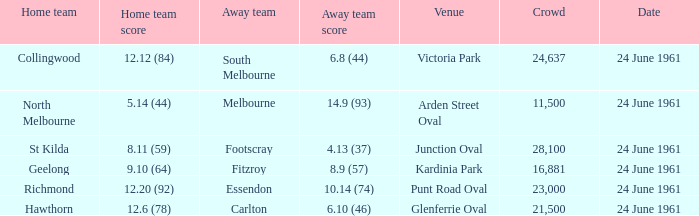What is the date of the match where the home team scored 24 June 1961. I'm looking to parse the entire table for insights. Could you assist me with that? {'header': ['Home team', 'Home team score', 'Away team', 'Away team score', 'Venue', 'Crowd', 'Date'], 'rows': [['Collingwood', '12.12 (84)', 'South Melbourne', '6.8 (44)', 'Victoria Park', '24,637', '24 June 1961'], ['North Melbourne', '5.14 (44)', 'Melbourne', '14.9 (93)', 'Arden Street Oval', '11,500', '24 June 1961'], ['St Kilda', '8.11 (59)', 'Footscray', '4.13 (37)', 'Junction Oval', '28,100', '24 June 1961'], ['Geelong', '9.10 (64)', 'Fitzroy', '8.9 (57)', 'Kardinia Park', '16,881', '24 June 1961'], ['Richmond', '12.20 (92)', 'Essendon', '10.14 (74)', 'Punt Road Oval', '23,000', '24 June 1961'], ['Hawthorn', '12.6 (78)', 'Carlton', '6.10 (46)', 'Glenferrie Oval', '21,500', '24 June 1961']]} 